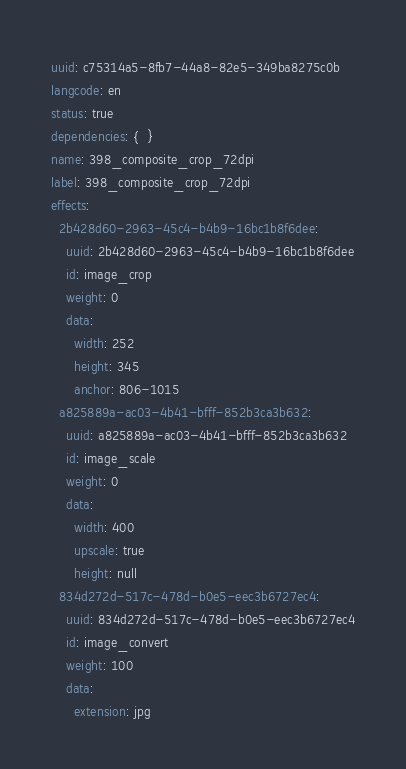Convert code to text. <code><loc_0><loc_0><loc_500><loc_500><_YAML_>uuid: c75314a5-8fb7-44a8-82e5-349ba8275c0b
langcode: en
status: true
dependencies: {  }
name: 398_composite_crop_72dpi
label: 398_composite_crop_72dpi
effects:
  2b428d60-2963-45c4-b4b9-16bc1b8f6dee:
    uuid: 2b428d60-2963-45c4-b4b9-16bc1b8f6dee
    id: image_crop
    weight: 0
    data:
      width: 252
      height: 345
      anchor: 806-1015
  a825889a-ac03-4b41-bfff-852b3ca3b632:
    uuid: a825889a-ac03-4b41-bfff-852b3ca3b632
    id: image_scale
    weight: 0
    data:
      width: 400
      upscale: true
      height: null
  834d272d-517c-478d-b0e5-eec3b6727ec4:
    uuid: 834d272d-517c-478d-b0e5-eec3b6727ec4
    id: image_convert
    weight: 100
    data:
      extension: jpg
</code> 